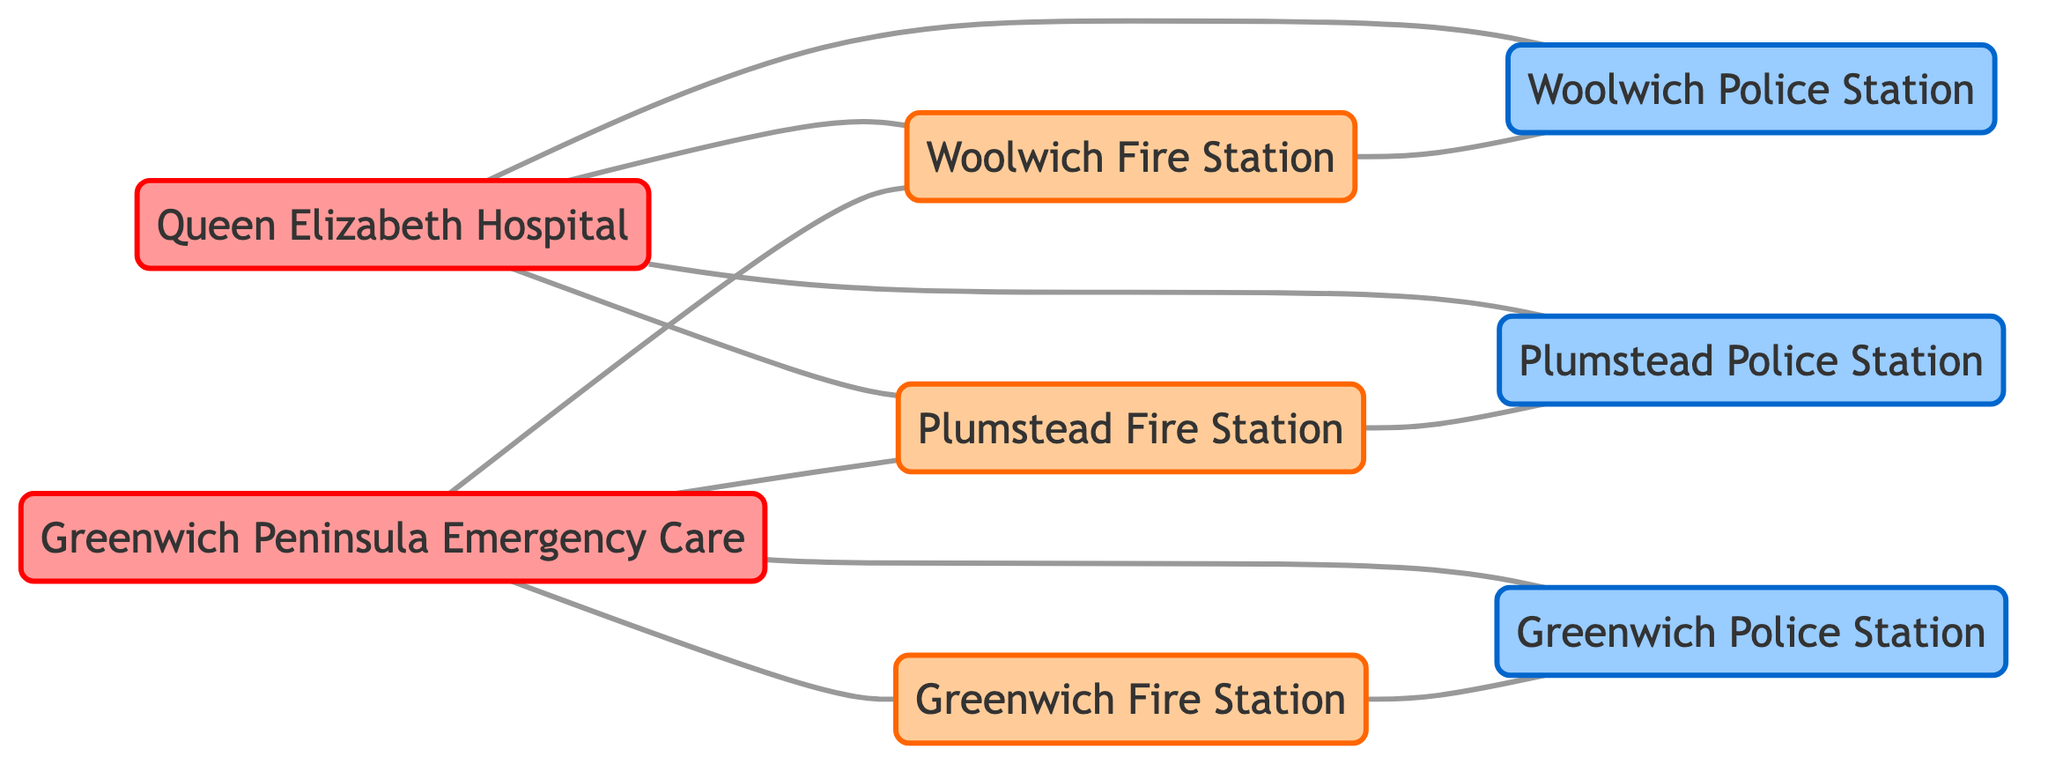What types of nodes are present in the diagram? The diagram consists of three types of nodes: hospitals, fire stations, and police stations. By examining the node definitions, we can see that there are 2 hospitals, 3 fire stations, and 2 police stations displayed in the network.
Answer: hospitals, fire stations, police stations How many total nodes are there in the emergency service network? The total number of nodes is calculated by adding up all unique nodes listed in the diagram: 2 hospitals + 3 fire stations + 2 police stations = 7 nodes in total.
Answer: 7 Which fire stations are connected to Queen Elizabeth Hospital? To find the connected fire stations, we look at the edges where Queen Elizabeth Hospital is the source. The edges connecting points show that both Woolwich Fire Station and Plumstead Fire Station are directly linked to it.
Answer: Woolwich Fire Station, Plumstead Fire Station Is there a direct connection between Woolwich Fire Station and Plumstead Police Station? By examining the edges, there is no direct edge connecting Woolwich Fire Station to Plumstead Police Station. Instead, we find that they are connected to other nodes, but not to each other.
Answer: No How many edges are connected to Greenwich Peninsula Emergency Care? We determine the number of edges by identifying every connection from Greenwich Peninsula Emergency Care to other nodes. There are four direct connections: Greenwich Fire Station, Greenwich Police Station, Plumstead Fire Station, and Woolwich Fire Station, indicating there are 4 edges connected to it.
Answer: 4 Which hospital is connected to the most number of emergency services? By reviewing the connections, we need to count the edges for each hospital. Queen Elizabeth Hospital has 4 connections, while Greenwich Peninsula Emergency Care also has 4. Both hospitals are equally connected to the emergency services.
Answer: Both hospitals What is the relationship between Plumstead Fire Station and Plumstead Police Station? Plumstead Fire Station and Plumstead Police Station are directly connected as indicated by an edge between them. This means they have a relationship in the network where they can operate in close coordination.
Answer: Direct connection How many total edges are in the emergency service network? To find the total number of edges, we count each connection listed in the edges array. After summing all unique connections, we find that there are 10 total edges in the network.
Answer: 10 What is the direct connection between the Greenwich Fire Station and the Greenwich Police Station? The edge between Greenwich Fire Station and Greenwich Police Station indicates that they have a direct connection in the network. Examining the edges shows that they are directly linked, allowing for immediate communication or response interaction.
Answer: Direct connection 